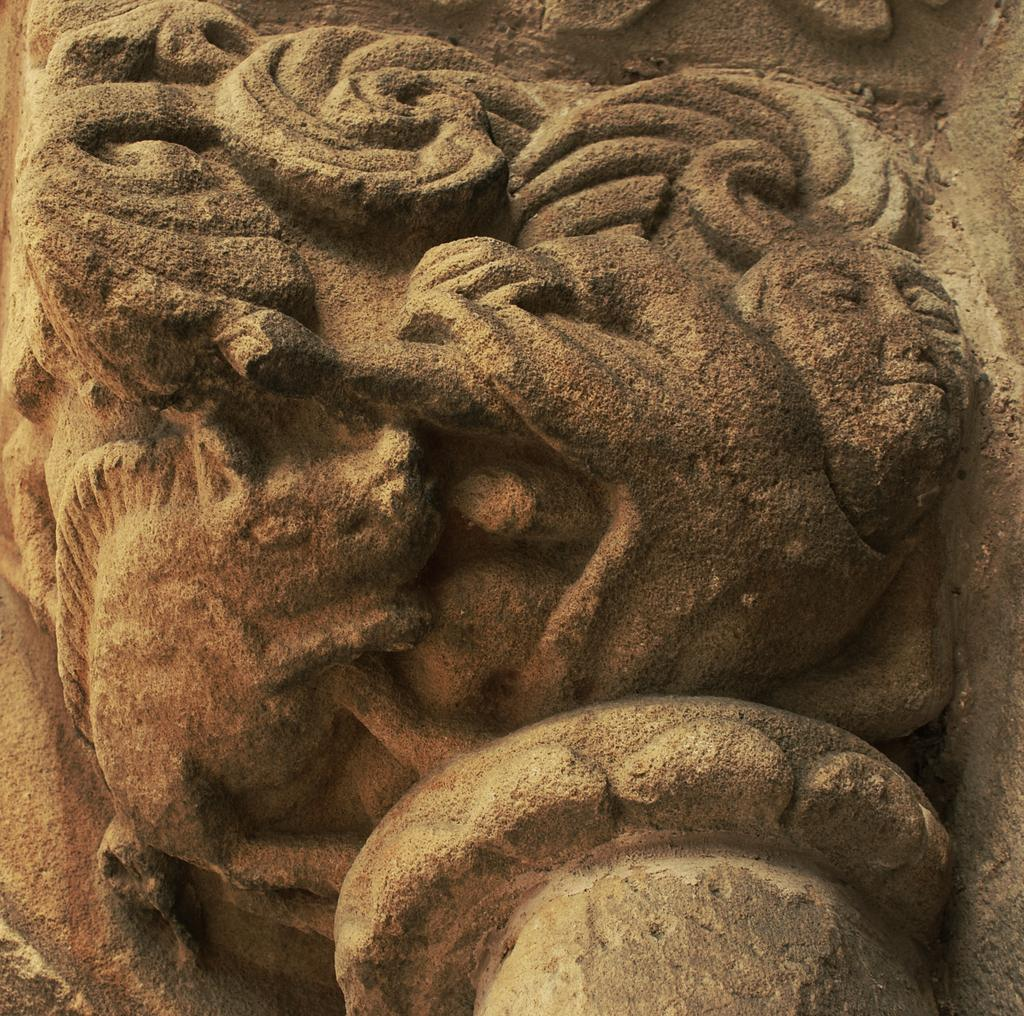What type of artwork is depicted in the image? There are stone carvings in the image. Can you describe the medium used for these carvings? The medium used for these carvings is stone. What might be the purpose of these stone carvings? The purpose of these stone carvings could be decorative, historical, or cultural. What type of birthday celebration is being advertised in the image? There is no birthday celebration or advertisement present in the image; it features stone carvings. What kind of beast can be seen interacting with the stone carvings in the image? There is no beast present in the image; it only features stone carvings. 